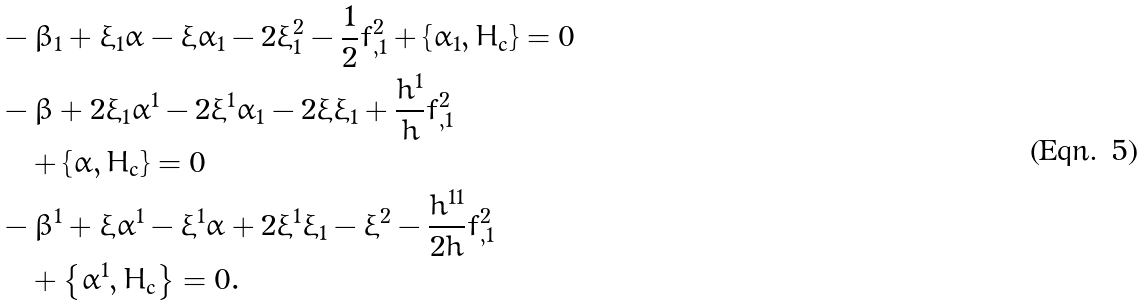<formula> <loc_0><loc_0><loc_500><loc_500>& - \beta _ { 1 } + \xi _ { 1 } \alpha - \xi \alpha _ { 1 } - 2 \xi _ { 1 } ^ { 2 } - \frac { 1 } { 2 } f _ { , 1 } ^ { 2 } + \left \{ \alpha _ { 1 } , H _ { c } \right \} = 0 \\ & - \beta + 2 \xi _ { 1 } \alpha ^ { 1 } - 2 \xi ^ { 1 } \alpha _ { 1 } - 2 \xi \xi _ { 1 } + \frac { h ^ { 1 } } { h } f _ { , 1 } ^ { 2 } \\ & \quad + \left \{ \alpha , H _ { c } \right \} = 0 \\ & - \beta ^ { 1 } + \xi \alpha ^ { 1 } - \xi ^ { 1 } \alpha + 2 \xi ^ { 1 } \xi _ { 1 } - \xi ^ { 2 } - \frac { h ^ { 1 1 } } { 2 h } f _ { , 1 } ^ { 2 } \\ & \quad + \left \{ \alpha ^ { 1 } , H _ { c } \right \} = 0 .</formula> 